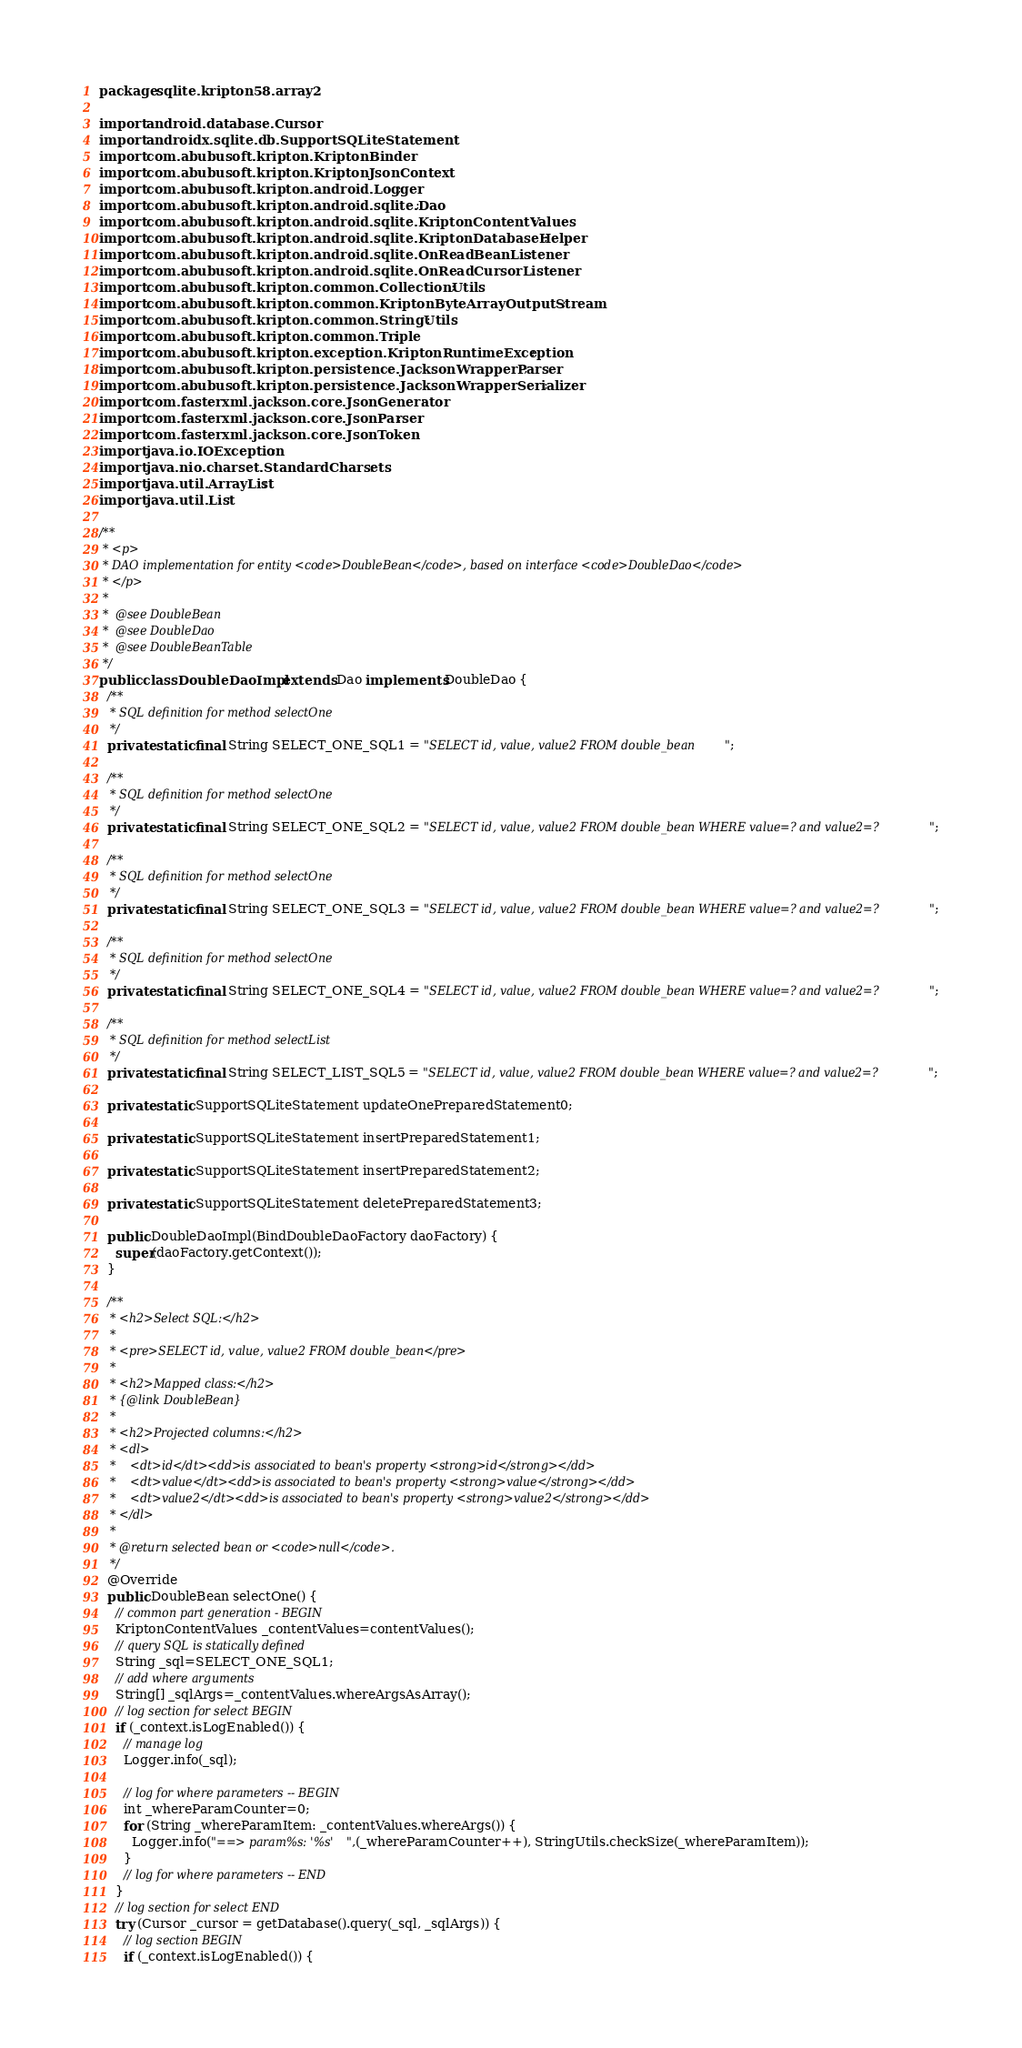<code> <loc_0><loc_0><loc_500><loc_500><_Java_>package sqlite.kripton58.array2;

import android.database.Cursor;
import androidx.sqlite.db.SupportSQLiteStatement;
import com.abubusoft.kripton.KriptonBinder;
import com.abubusoft.kripton.KriptonJsonContext;
import com.abubusoft.kripton.android.Logger;
import com.abubusoft.kripton.android.sqlite.Dao;
import com.abubusoft.kripton.android.sqlite.KriptonContentValues;
import com.abubusoft.kripton.android.sqlite.KriptonDatabaseHelper;
import com.abubusoft.kripton.android.sqlite.OnReadBeanListener;
import com.abubusoft.kripton.android.sqlite.OnReadCursorListener;
import com.abubusoft.kripton.common.CollectionUtils;
import com.abubusoft.kripton.common.KriptonByteArrayOutputStream;
import com.abubusoft.kripton.common.StringUtils;
import com.abubusoft.kripton.common.Triple;
import com.abubusoft.kripton.exception.KriptonRuntimeException;
import com.abubusoft.kripton.persistence.JacksonWrapperParser;
import com.abubusoft.kripton.persistence.JacksonWrapperSerializer;
import com.fasterxml.jackson.core.JsonGenerator;
import com.fasterxml.jackson.core.JsonParser;
import com.fasterxml.jackson.core.JsonToken;
import java.io.IOException;
import java.nio.charset.StandardCharsets;
import java.util.ArrayList;
import java.util.List;

/**
 * <p>
 * DAO implementation for entity <code>DoubleBean</code>, based on interface <code>DoubleDao</code>
 * </p>
 *
 *  @see DoubleBean
 *  @see DoubleDao
 *  @see DoubleBeanTable
 */
public class DoubleDaoImpl extends Dao implements DoubleDao {
  /**
   * SQL definition for method selectOne
   */
  private static final String SELECT_ONE_SQL1 = "SELECT id, value, value2 FROM double_bean";

  /**
   * SQL definition for method selectOne
   */
  private static final String SELECT_ONE_SQL2 = "SELECT id, value, value2 FROM double_bean WHERE value=? and value2=?";

  /**
   * SQL definition for method selectOne
   */
  private static final String SELECT_ONE_SQL3 = "SELECT id, value, value2 FROM double_bean WHERE value=? and value2=?";

  /**
   * SQL definition for method selectOne
   */
  private static final String SELECT_ONE_SQL4 = "SELECT id, value, value2 FROM double_bean WHERE value=? and value2=?";

  /**
   * SQL definition for method selectList
   */
  private static final String SELECT_LIST_SQL5 = "SELECT id, value, value2 FROM double_bean WHERE value=? and value2=?";

  private static SupportSQLiteStatement updateOnePreparedStatement0;

  private static SupportSQLiteStatement insertPreparedStatement1;

  private static SupportSQLiteStatement insertPreparedStatement2;

  private static SupportSQLiteStatement deletePreparedStatement3;

  public DoubleDaoImpl(BindDoubleDaoFactory daoFactory) {
    super(daoFactory.getContext());
  }

  /**
   * <h2>Select SQL:</h2>
   *
   * <pre>SELECT id, value, value2 FROM double_bean</pre>
   *
   * <h2>Mapped class:</h2>
   * {@link DoubleBean}
   *
   * <h2>Projected columns:</h2>
   * <dl>
   * 	<dt>id</dt><dd>is associated to bean's property <strong>id</strong></dd>
   * 	<dt>value</dt><dd>is associated to bean's property <strong>value</strong></dd>
   * 	<dt>value2</dt><dd>is associated to bean's property <strong>value2</strong></dd>
   * </dl>
   *
   * @return selected bean or <code>null</code>.
   */
  @Override
  public DoubleBean selectOne() {
    // common part generation - BEGIN
    KriptonContentValues _contentValues=contentValues();
    // query SQL is statically defined
    String _sql=SELECT_ONE_SQL1;
    // add where arguments
    String[] _sqlArgs=_contentValues.whereArgsAsArray();
    // log section for select BEGIN
    if (_context.isLogEnabled()) {
      // manage log
      Logger.info(_sql);

      // log for where parameters -- BEGIN
      int _whereParamCounter=0;
      for (String _whereParamItem: _contentValues.whereArgs()) {
        Logger.info("==> param%s: '%s'",(_whereParamCounter++), StringUtils.checkSize(_whereParamItem));
      }
      // log for where parameters -- END
    }
    // log section for select END
    try (Cursor _cursor = getDatabase().query(_sql, _sqlArgs)) {
      // log section BEGIN
      if (_context.isLogEnabled()) {</code> 